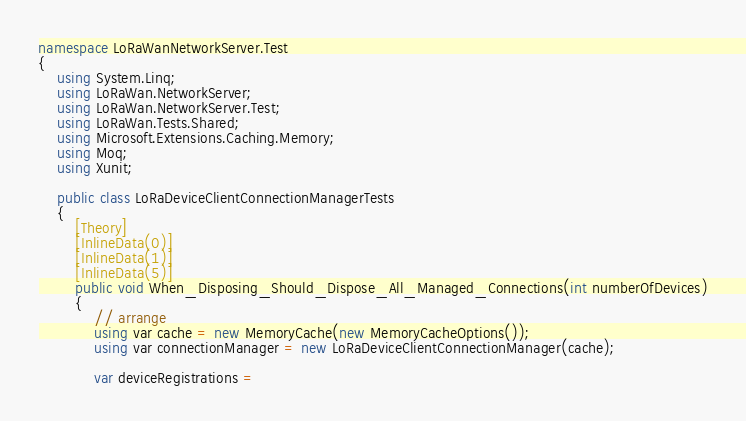Convert code to text. <code><loc_0><loc_0><loc_500><loc_500><_C#_>namespace LoRaWanNetworkServer.Test
{
    using System.Linq;
    using LoRaWan.NetworkServer;
    using LoRaWan.NetworkServer.Test;
    using LoRaWan.Tests.Shared;
    using Microsoft.Extensions.Caching.Memory;
    using Moq;
    using Xunit;

    public class LoRaDeviceClientConnectionManagerTests
    {
        [Theory]
        [InlineData(0)]
        [InlineData(1)]
        [InlineData(5)]
        public void When_Disposing_Should_Dispose_All_Managed_Connections(int numberOfDevices)
        {
            // arrange
            using var cache = new MemoryCache(new MemoryCacheOptions());
            using var connectionManager = new LoRaDeviceClientConnectionManager(cache);

            var deviceRegistrations =</code> 